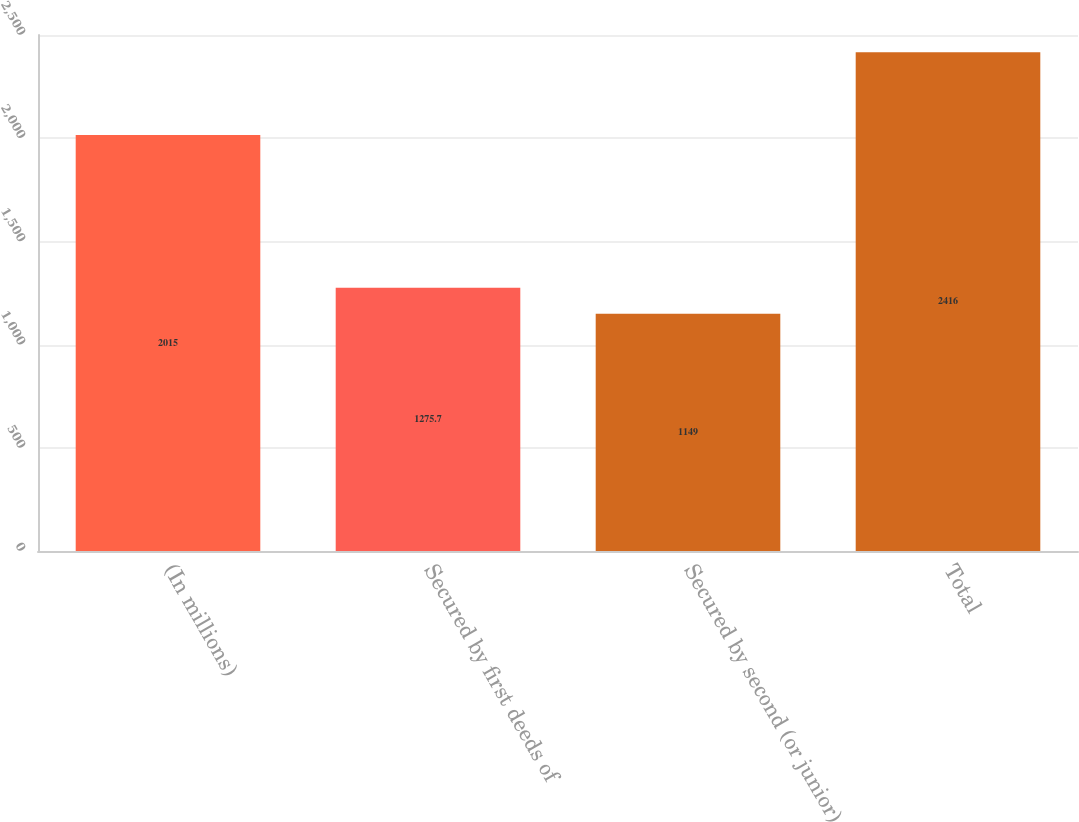Convert chart to OTSL. <chart><loc_0><loc_0><loc_500><loc_500><bar_chart><fcel>(In millions)<fcel>Secured by first deeds of<fcel>Secured by second (or junior)<fcel>Total<nl><fcel>2015<fcel>1275.7<fcel>1149<fcel>2416<nl></chart> 